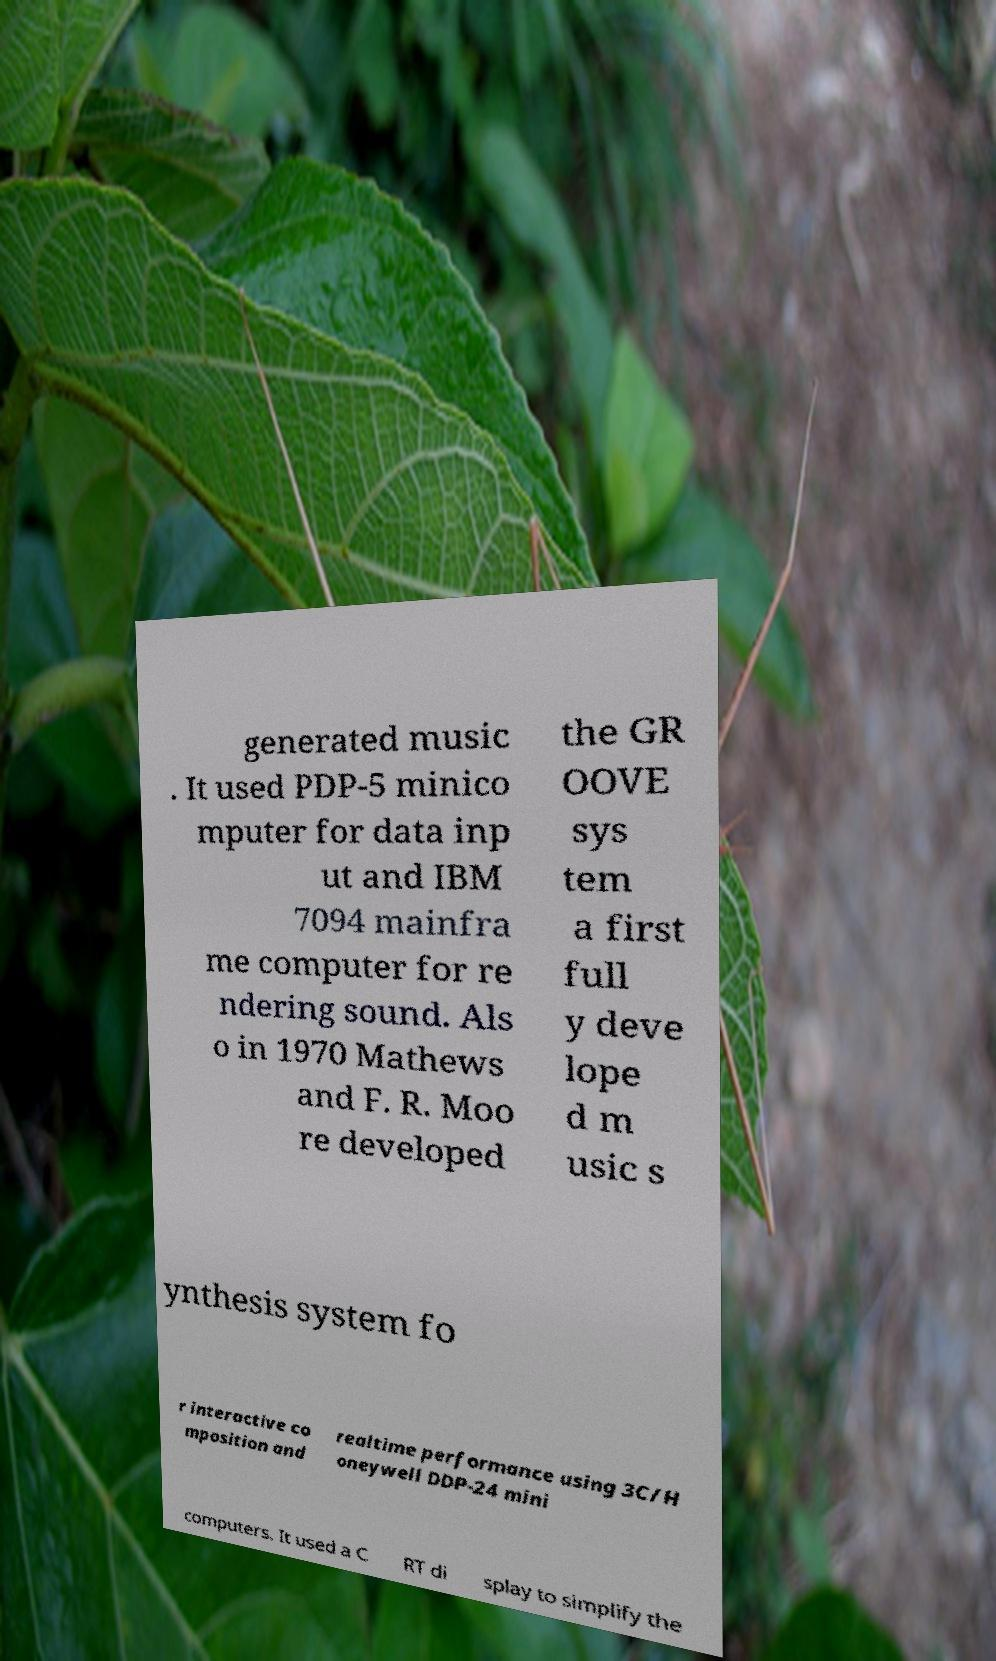For documentation purposes, I need the text within this image transcribed. Could you provide that? generated music . It used PDP-5 minico mputer for data inp ut and IBM 7094 mainfra me computer for re ndering sound. Als o in 1970 Mathews and F. R. Moo re developed the GR OOVE sys tem a first full y deve lope d m usic s ynthesis system fo r interactive co mposition and realtime performance using 3C/H oneywell DDP-24 mini computers. It used a C RT di splay to simplify the 